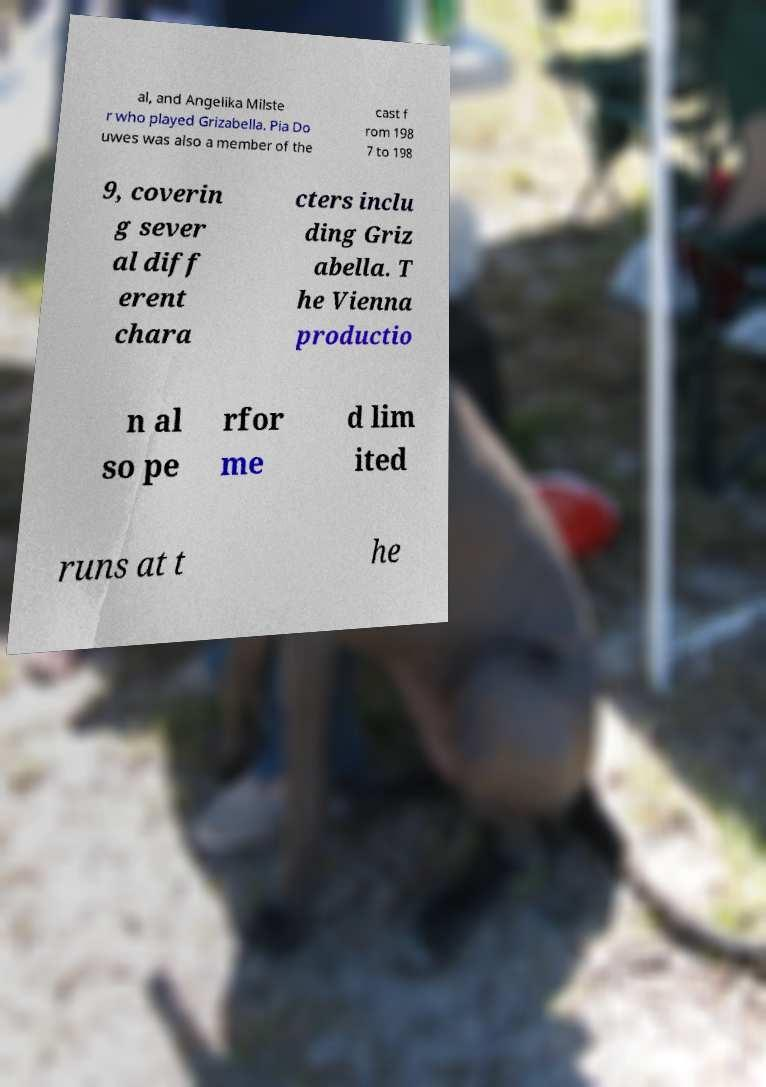Could you assist in decoding the text presented in this image and type it out clearly? al, and Angelika Milste r who played Grizabella. Pia Do uwes was also a member of the cast f rom 198 7 to 198 9, coverin g sever al diff erent chara cters inclu ding Griz abella. T he Vienna productio n al so pe rfor me d lim ited runs at t he 